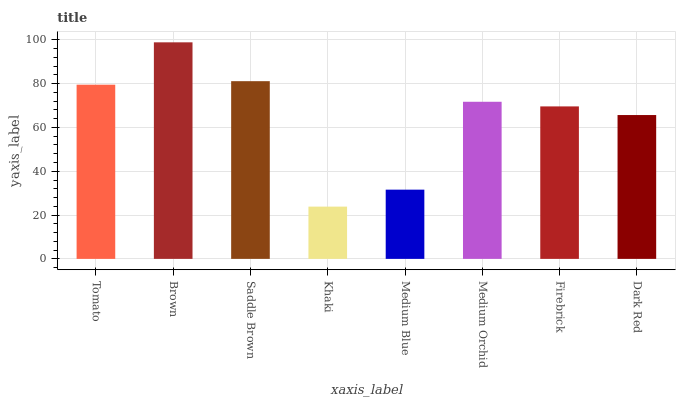Is Khaki the minimum?
Answer yes or no. Yes. Is Brown the maximum?
Answer yes or no. Yes. Is Saddle Brown the minimum?
Answer yes or no. No. Is Saddle Brown the maximum?
Answer yes or no. No. Is Brown greater than Saddle Brown?
Answer yes or no. Yes. Is Saddle Brown less than Brown?
Answer yes or no. Yes. Is Saddle Brown greater than Brown?
Answer yes or no. No. Is Brown less than Saddle Brown?
Answer yes or no. No. Is Medium Orchid the high median?
Answer yes or no. Yes. Is Firebrick the low median?
Answer yes or no. Yes. Is Brown the high median?
Answer yes or no. No. Is Brown the low median?
Answer yes or no. No. 